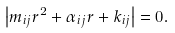<formula> <loc_0><loc_0><loc_500><loc_500>\left | m _ { i j } r ^ { 2 } + \alpha _ { i j } r + k _ { i j } \right | = 0 .</formula> 